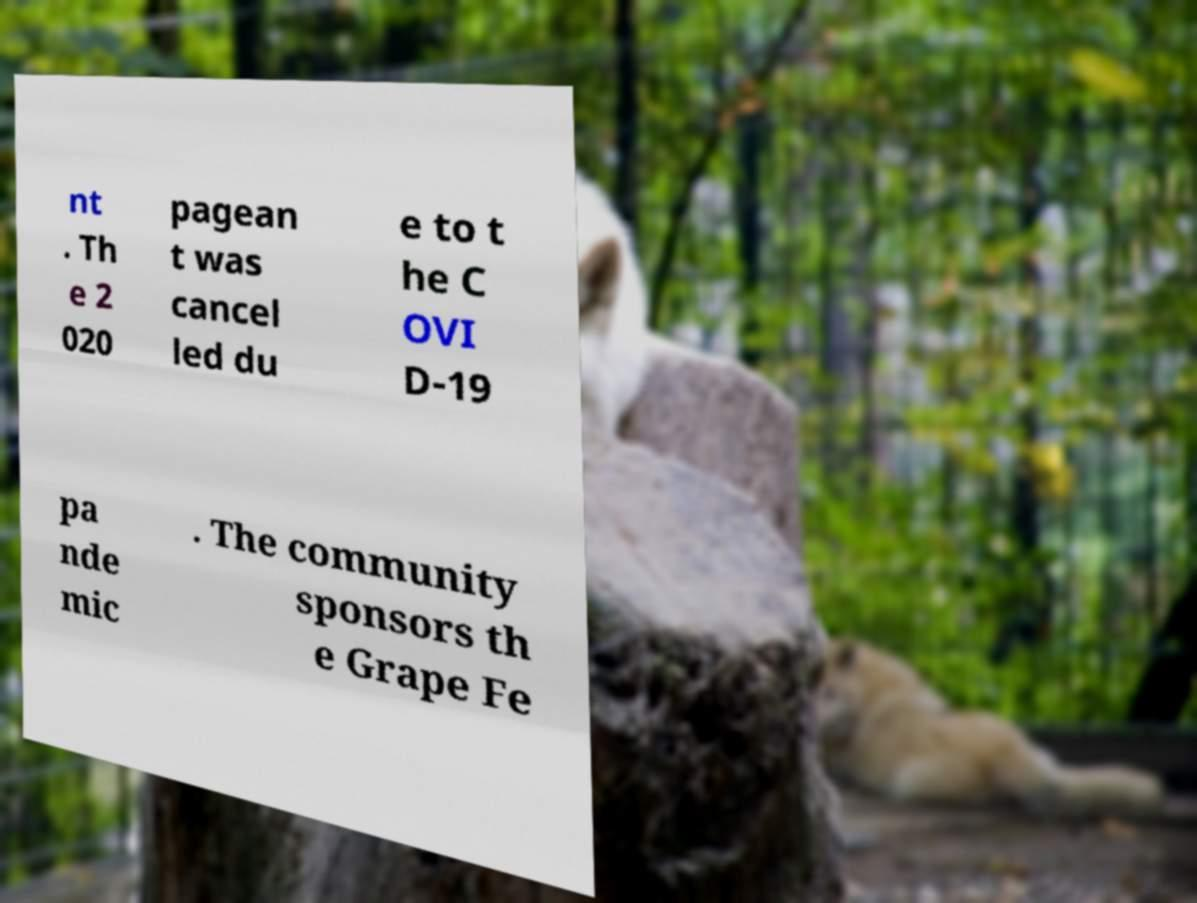Can you accurately transcribe the text from the provided image for me? nt . Th e 2 020 pagean t was cancel led du e to t he C OVI D-19 pa nde mic . The community sponsors th e Grape Fe 